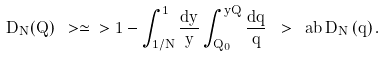<formula> <loc_0><loc_0><loc_500><loc_500>D _ { N } ( Q ) \ > \simeq \ > 1 - \int ^ { 1 } _ { 1 / N } \frac { d y } { y } \int ^ { y Q } _ { Q _ { 0 } } \frac { d q } { q } \ > \ a b \, D _ { N } \left ( q \right ) .</formula> 